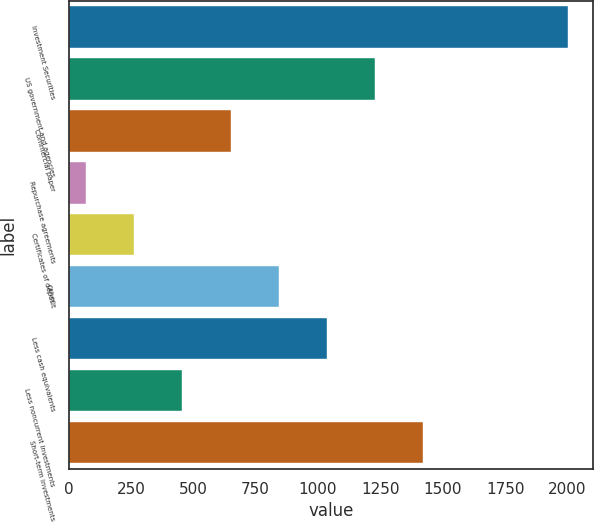<chart> <loc_0><loc_0><loc_500><loc_500><bar_chart><fcel>Investment Securities<fcel>US government and agencies<fcel>Commercial paper<fcel>Repurchase agreements<fcel>Certificates of deposit<fcel>Other<fcel>Less cash equivalents<fcel>Less noncurrent investments<fcel>Short-term investments<nl><fcel>2002<fcel>1229.2<fcel>649.6<fcel>70<fcel>263.2<fcel>842.8<fcel>1036<fcel>456.4<fcel>1422.4<nl></chart> 